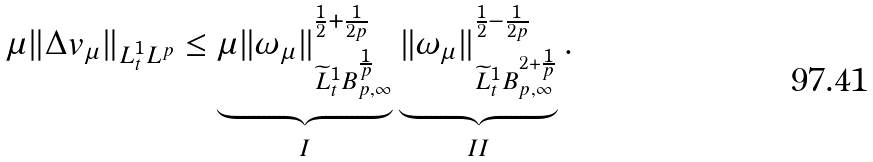<formula> <loc_0><loc_0><loc_500><loc_500>\mu \| \Delta v _ { \mu } \| _ { L _ { t } ^ { 1 } L ^ { p } } \leq \underbrace { \mu \| \omega _ { \mu } \| _ { \widetilde { L } _ { t } ^ { 1 } B _ { p , \infty } ^ { \frac { 1 } { p } } } ^ { \frac { 1 } { 2 } + \frac { 1 } { 2 p } } } _ { I } \underbrace { \| \omega _ { \mu } \| _ { \widetilde { L } _ { t } ^ { 1 } B _ { p , \infty } ^ { 2 + \frac { 1 } { p } } } ^ { \frac { 1 } { 2 } - \frac { 1 } { 2 p } } } _ { I I } .</formula> 